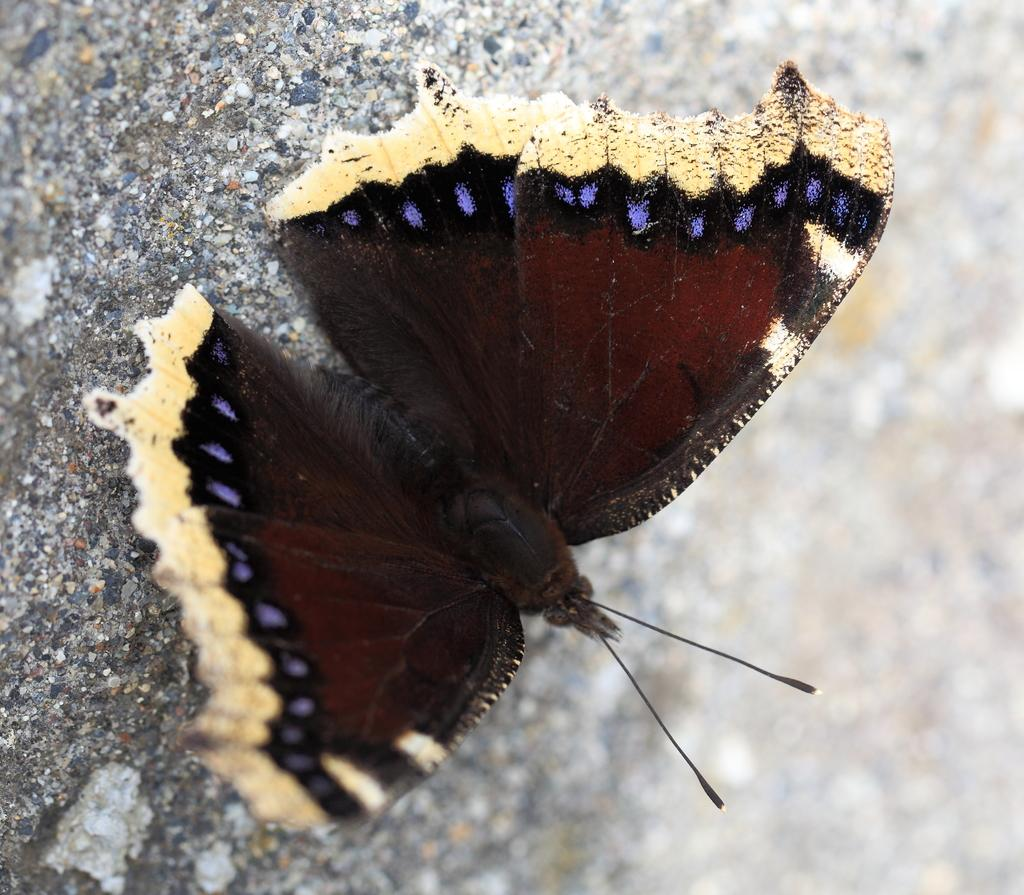What type of creature is present in the image? There is a butterfly in the image. Where is the butterfly located? The butterfly is on a surface. What type of religious symbol can be seen in the image? There is no religious symbol present in the image; it features a butterfly on a surface. How many eggs are visible in the image? There are no eggs present in the image. 